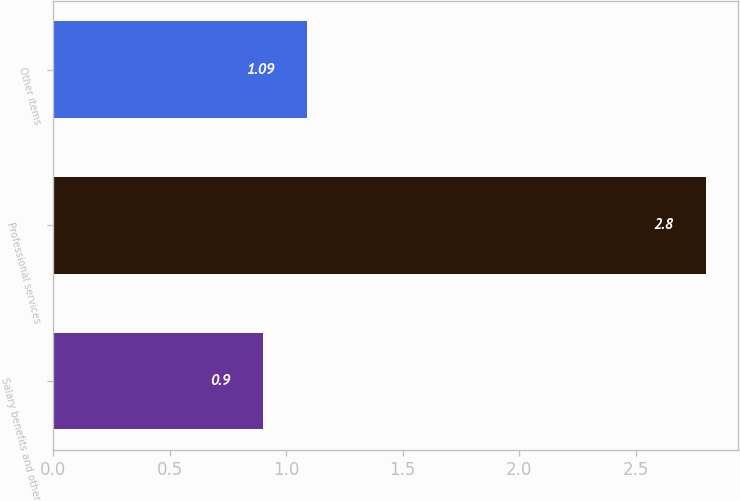<chart> <loc_0><loc_0><loc_500><loc_500><bar_chart><fcel>Salary benefits and other<fcel>Professional services<fcel>Other items<nl><fcel>0.9<fcel>2.8<fcel>1.09<nl></chart> 